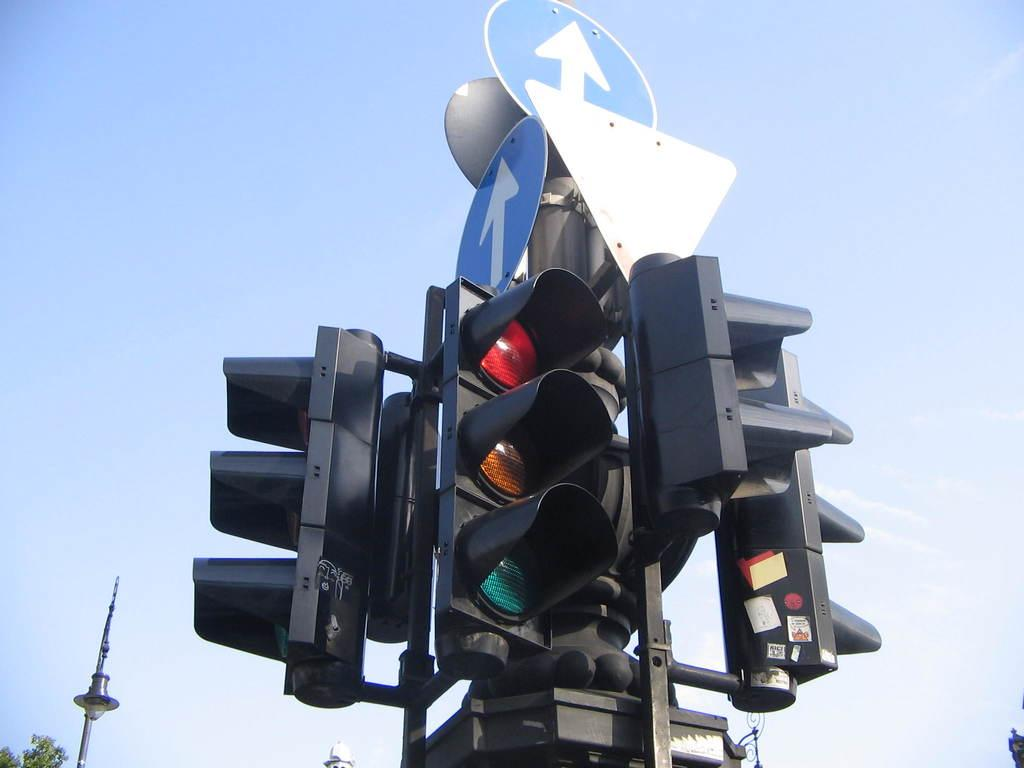What type of traffic control devices are present in the image? There are signal lights in the image. What other information is displayed in the image? There are sign boards in the image. What structure is supporting the signal lights and sign boards? There is a light pole in the image. What can be seen in the background of the image? The sky is visible in the image. Can you tell me how many berries are growing on the light pole in the image? There are no berries present on the light pole in the image. What type of death is depicted in the image? There is no depiction of death in the image; it features traffic control devices and a light pole. 